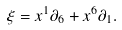Convert formula to latex. <formula><loc_0><loc_0><loc_500><loc_500>\xi = x ^ { 1 } \partial _ { 6 } + x ^ { 6 } \partial _ { 1 } .</formula> 